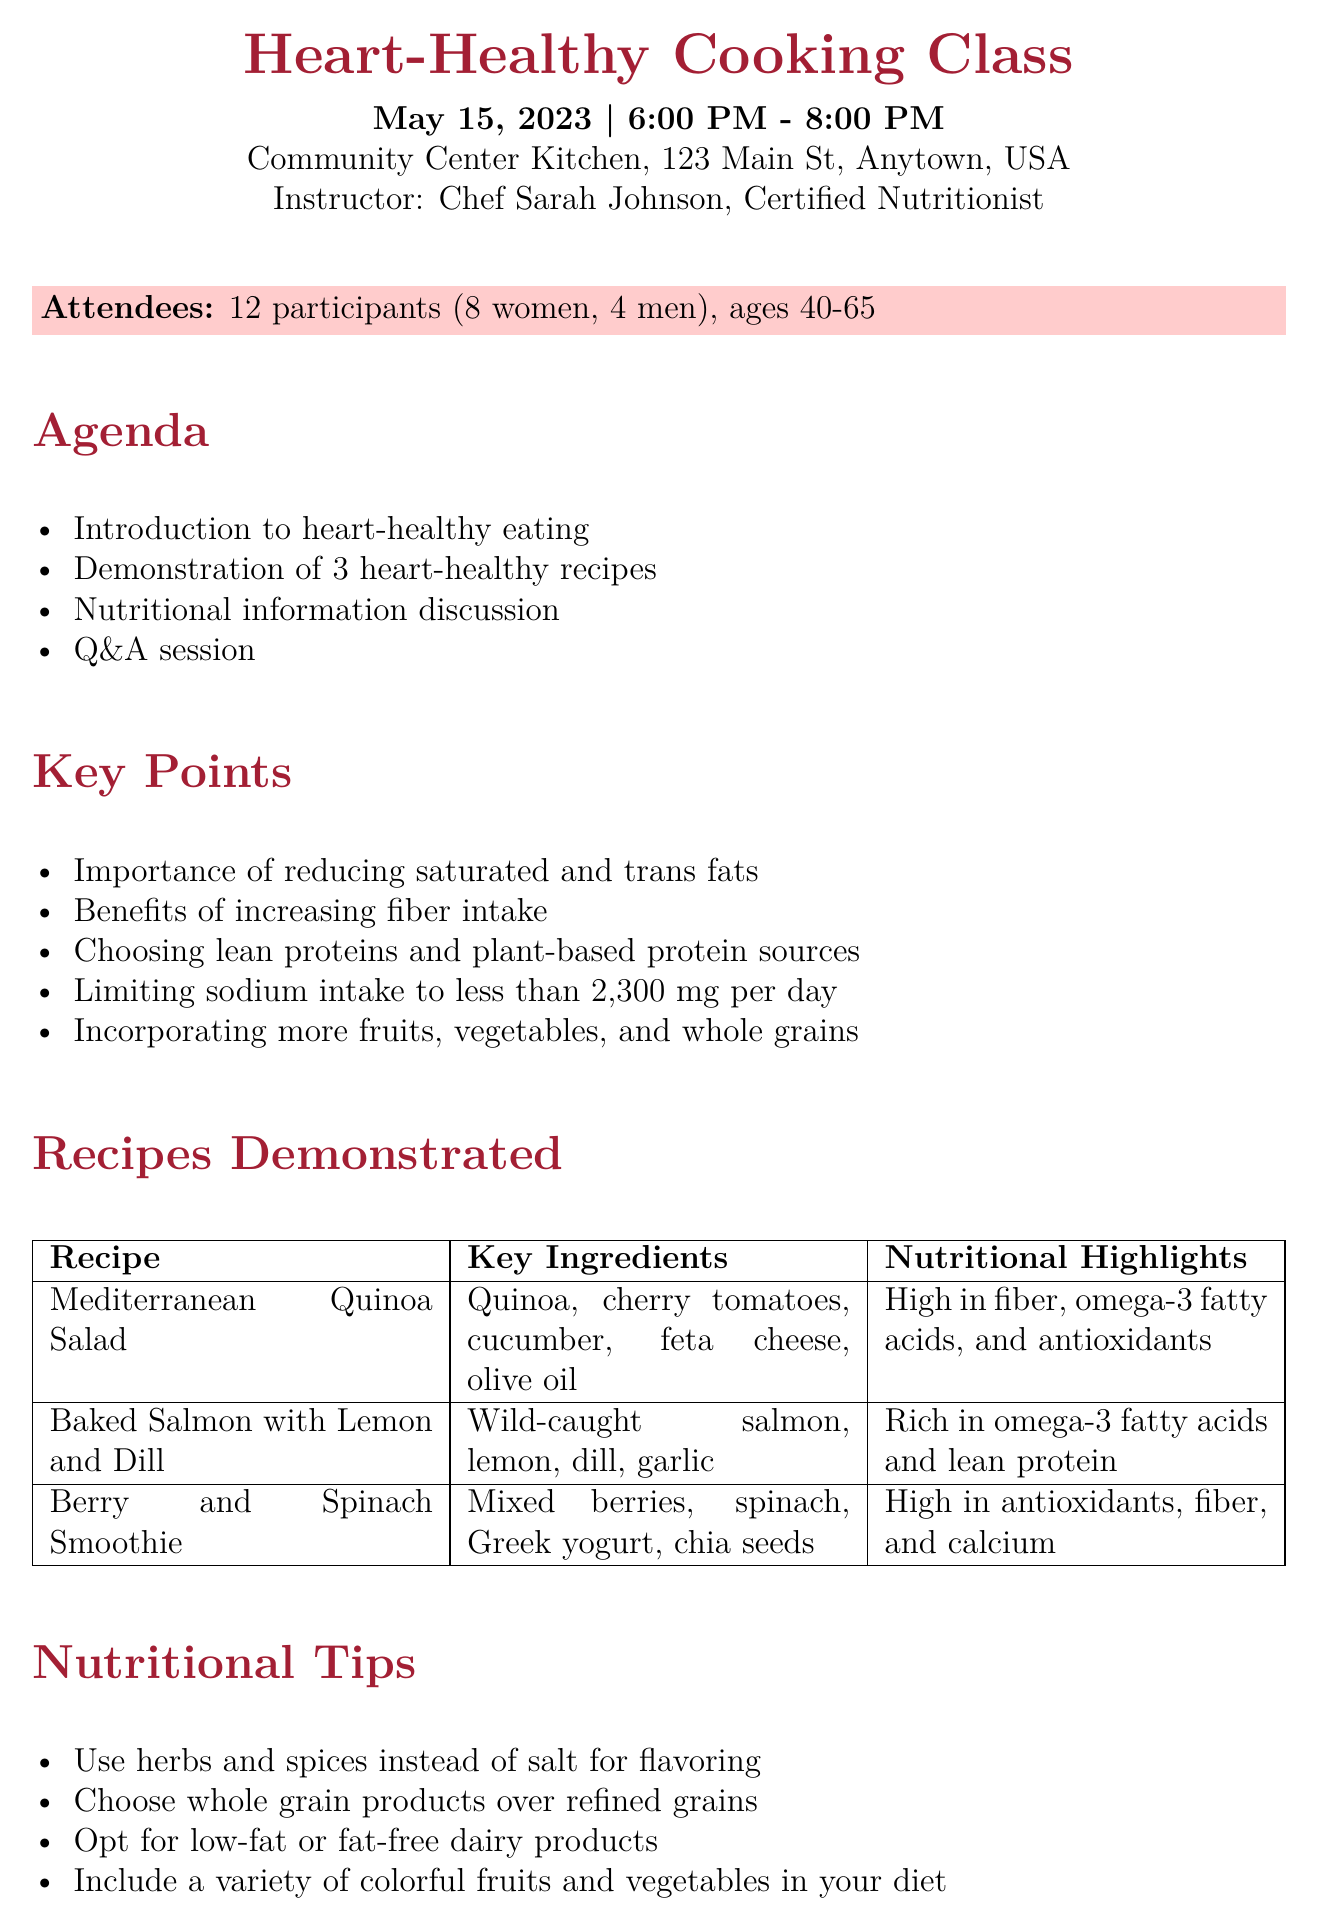What is the title of the event? The title is stated at the beginning of the document and reads, "Heart-Healthy Cooking Class."
Answer: Heart-Healthy Cooking Class Who was the instructor of the class? The instructor's name is mentioned in the meeting details section of the document, indicating their qualifications as a Certified Nutritionist.
Answer: Chef Sarah Johnson How many attendees were there? The number of attendees is provided in a summary at the beginning of the document, which indicates a total of 12 participants.
Answer: 12 participants What is one key ingredient in the Mediterranean Quinoa Salad? The document lists the key ingredients for each recipe, with the Mediterranean Quinoa Salad specifically including quinoa as one of them.
Answer: Quinoa What is one nutritional highlight of the Baked Salmon with Lemon and Dill? The document provides nutritional highlights for each recipe; for the Baked Salmon it states that it is rich in omega-3 fatty acids.
Answer: Rich in omega-3 fatty acids What is the date of the follow-up class? The follow-up class date is mentioned in the next steps section of the document, providing clarity on when participants can attend again.
Answer: June 12, 2023 What type of resources were provided to participants? The resources provided section lists items given to participants, which specifically includes a cookbook and other helpful information.
Answer: American Heart Association cookbook Why is increasing fiber intake important? This point is addressed among the key points discussed in the class and relates to overall heart health.
Answer: Benefits of increasing fiber intake 